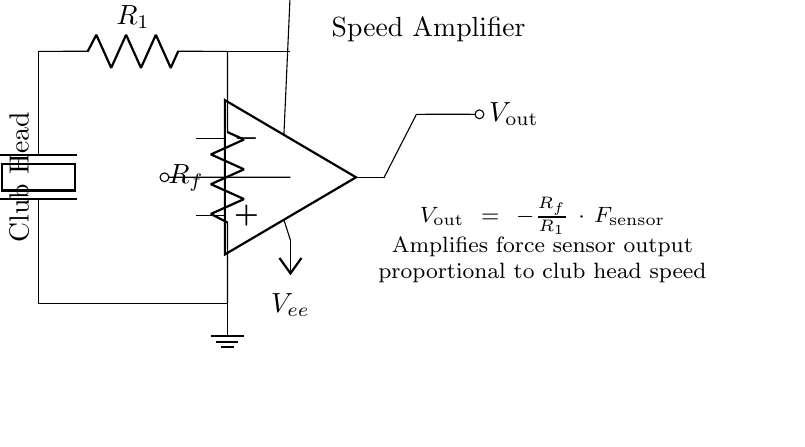What is the type of sensor used in this circuit? The circuit utilizes a piezoelectric sensor, indicated by the label next to the force sensor. Piezoelectric sensors generate a voltage when mechanical stress is applied, making them suitable for measuring force.
Answer: Piezoelectric What is the function of the resistor labeled R1? Resistor R1 is part of the feedback network of the op-amp and impacts the gain of the amplifier circuit. In the equation provided, it is used to determine the output voltage relative to the input from the force sensor.
Answer: Gain control What does the symbol labeled Vout represent in this circuit? Vout represents the output voltage of the op-amp relative to the input from the force sensor. It is the amplified signal that indicates the strength of the force measured, proportional to club head speed.
Answer: Output voltage How does the output voltage relate to the force sensor? The output voltage is calculated using the formula given in the circuit, which shows that Vout is proportional to the force sensor output, multiplied by the ratio of resistors, thus providing a way to interpret the sensor's measurement as a voltage.
Answer: Proportional What are the voltage levels used to power the op-amp? The op-amp is powered by two voltage rails, indicated as Vcc (positive) and Vee (negative), which provide the necessary supply voltages for proper operation of the amplifier.
Answer: Vcc and Vee What is the role of the feedback resistor labeled Rf? Resistor Rf, along with R1, helps to set the gain of the amplifier, which determines how much the input signal from the force sensor will be amplified at the output. It is crucial for controlling the sensitivity of the measurement.
Answer: Gain setting 